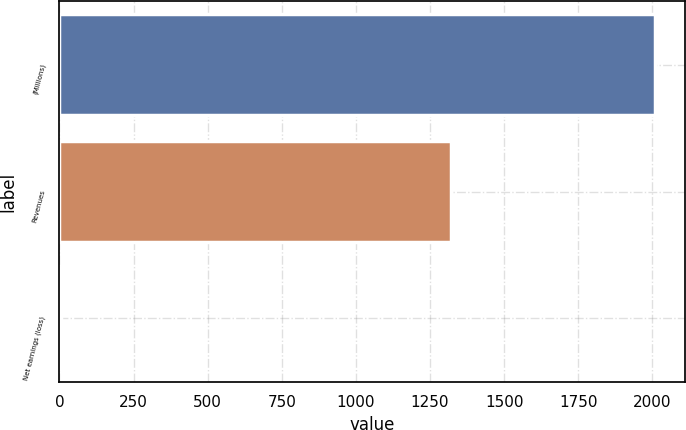Convert chart. <chart><loc_0><loc_0><loc_500><loc_500><bar_chart><fcel>(Millions)<fcel>Revenues<fcel>Net earnings (loss)<nl><fcel>2009<fcel>1320<fcel>4<nl></chart> 